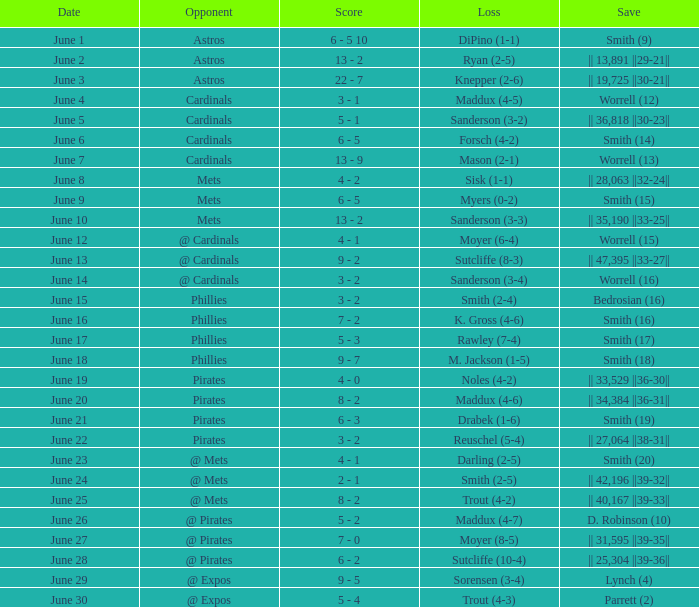What is the date for the contest that featured a loss of sutcliffe (10-4)? June 28. 